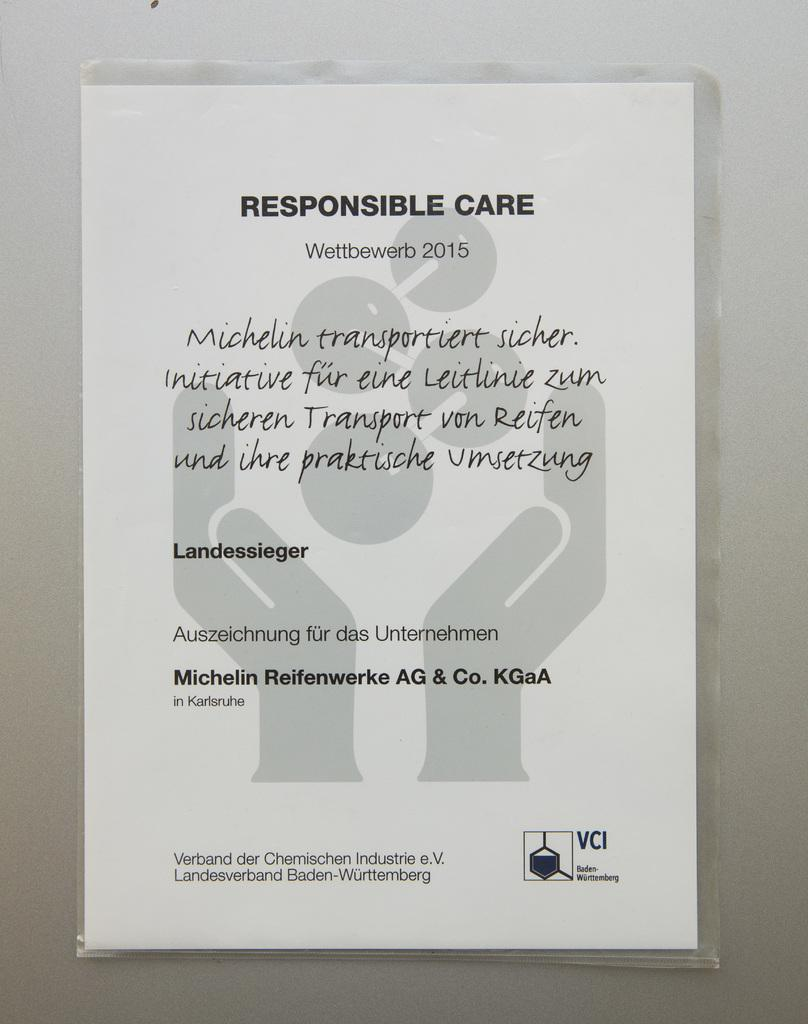What is the main subject of the image? The main subject of the image is a care sheet. What message is conveyed on the care sheet? The care sheet has the words "responsible care" written on it. What grade does the hen receive on the care sheet? There is no hen present on the care sheet, and therefore no grade can be assigned. 